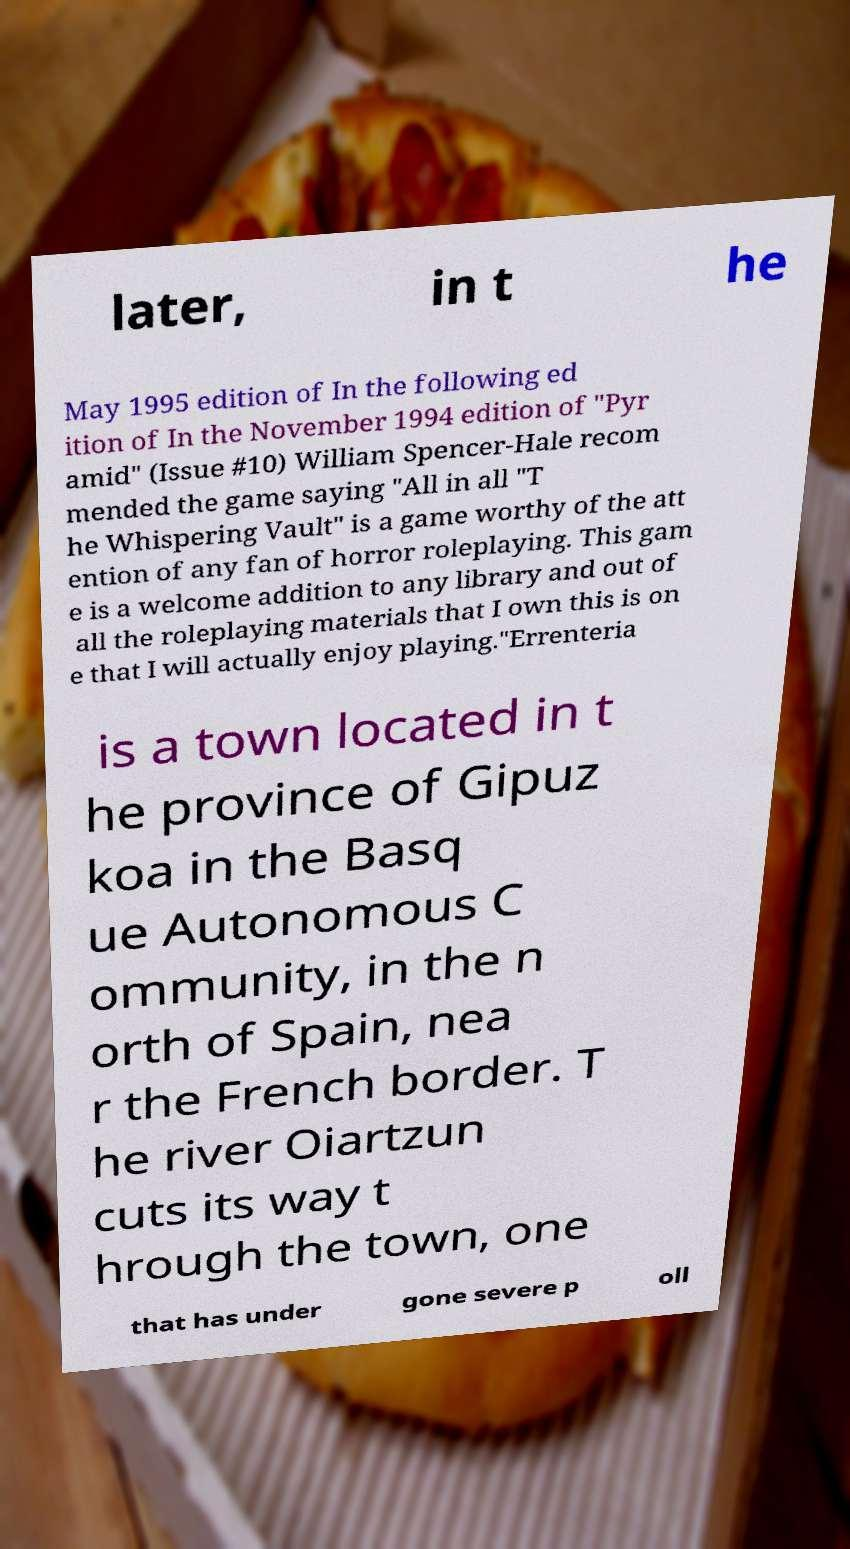I need the written content from this picture converted into text. Can you do that? later, in t he May 1995 edition of In the following ed ition of In the November 1994 edition of "Pyr amid" (Issue #10) William Spencer-Hale recom mended the game saying "All in all "T he Whispering Vault" is a game worthy of the att ention of any fan of horror roleplaying. This gam e is a welcome addition to any library and out of all the roleplaying materials that I own this is on e that I will actually enjoy playing."Errenteria is a town located in t he province of Gipuz koa in the Basq ue Autonomous C ommunity, in the n orth of Spain, nea r the French border. T he river Oiartzun cuts its way t hrough the town, one that has under gone severe p oll 